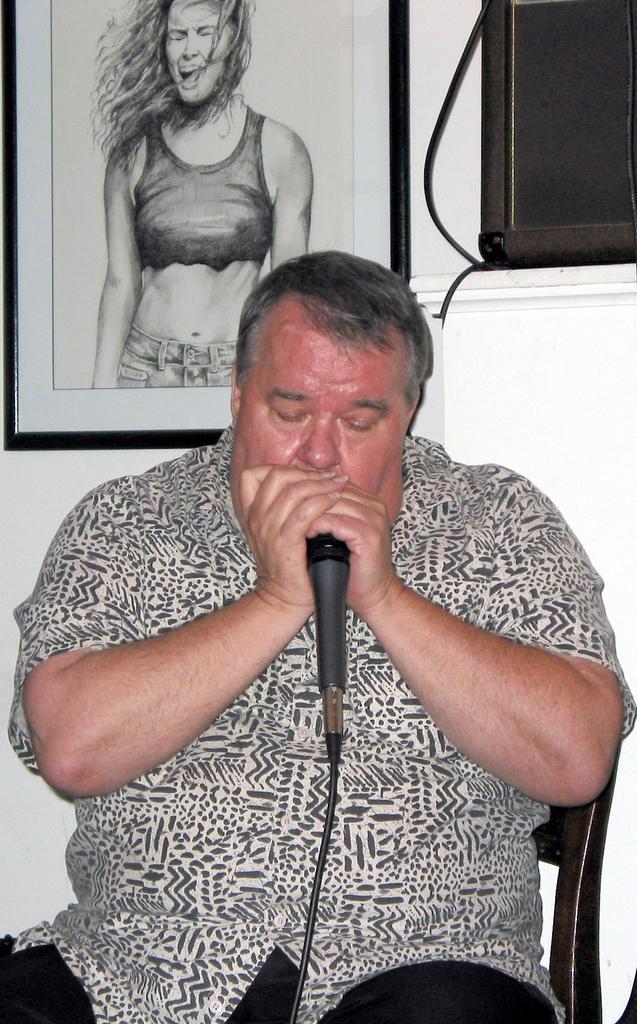How would you summarize this image in a sentence or two? In the middle of the image a man is sitting on a chair and holding a microphone. Behind him there is a wall, on the wall there is a frame. 